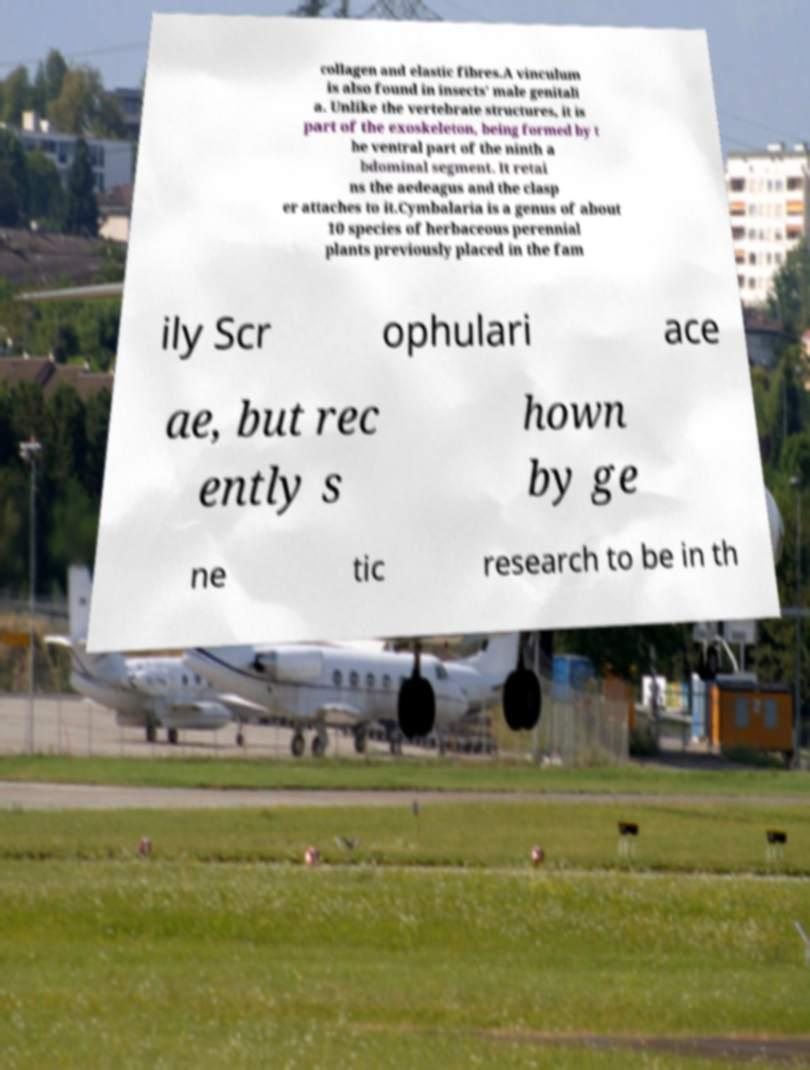For documentation purposes, I need the text within this image transcribed. Could you provide that? collagen and elastic fibres.A vinculum is also found in insects' male genitali a. Unlike the vertebrate structures, it is part of the exoskeleton, being formed by t he ventral part of the ninth a bdominal segment. It retai ns the aedeagus and the clasp er attaches to it.Cymbalaria is a genus of about 10 species of herbaceous perennial plants previously placed in the fam ily Scr ophulari ace ae, but rec ently s hown by ge ne tic research to be in th 